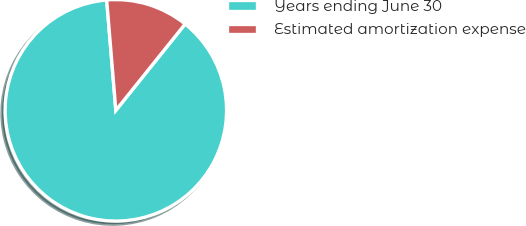<chart> <loc_0><loc_0><loc_500><loc_500><pie_chart><fcel>Years ending June 30<fcel>Estimated amortization expense<nl><fcel>87.92%<fcel>12.08%<nl></chart> 